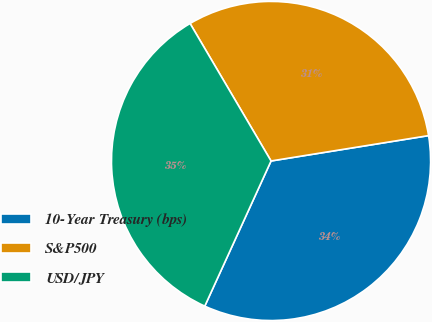Convert chart to OTSL. <chart><loc_0><loc_0><loc_500><loc_500><pie_chart><fcel>10-Year Treasury (bps)<fcel>S&P500<fcel>USD/JPY<nl><fcel>34.36%<fcel>30.93%<fcel>34.71%<nl></chart> 